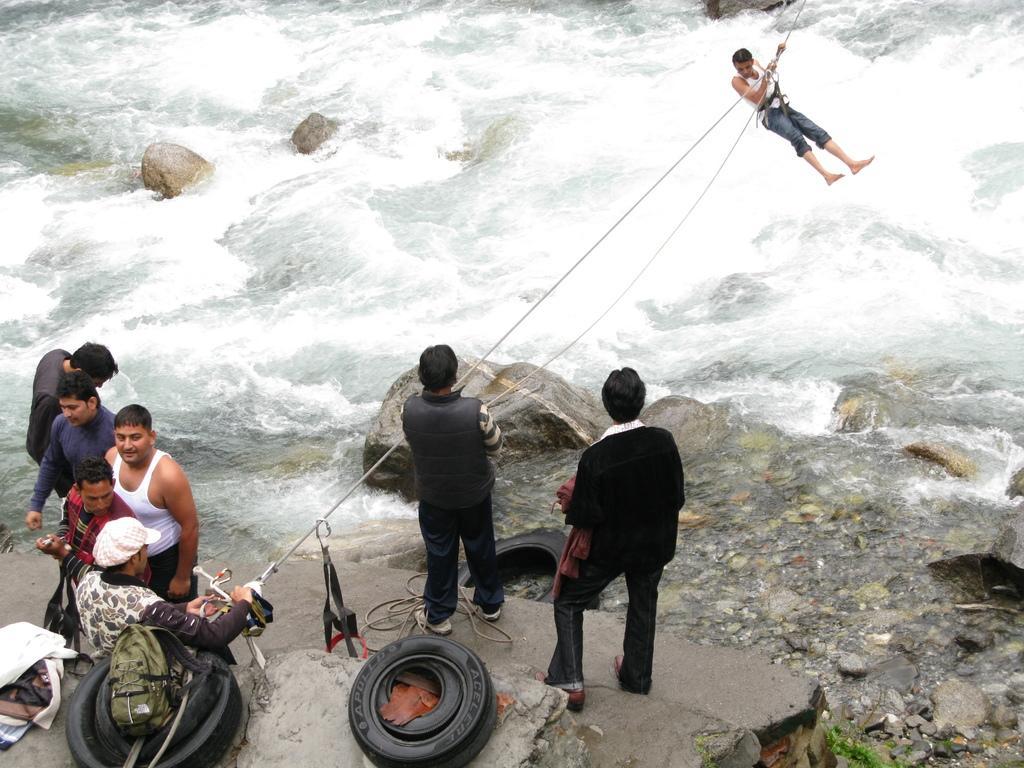In one or two sentences, can you explain what this image depicts? In this image, at the bottom we can see many people standing at the top, I can see a person hanging to the ropes and in the background I can see the water and rocks, at the bottom we can see some tires. 